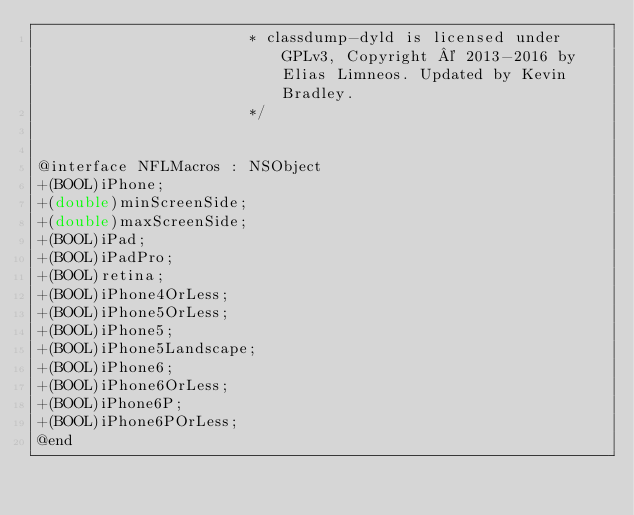<code> <loc_0><loc_0><loc_500><loc_500><_C_>                       * classdump-dyld is licensed under GPLv3, Copyright © 2013-2016 by Elias Limneos. Updated by Kevin Bradley.
                       */


@interface NFLMacros : NSObject
+(BOOL)iPhone;
+(double)minScreenSide;
+(double)maxScreenSide;
+(BOOL)iPad;
+(BOOL)iPadPro;
+(BOOL)retina;
+(BOOL)iPhone4OrLess;
+(BOOL)iPhone5OrLess;
+(BOOL)iPhone5;
+(BOOL)iPhone5Landscape;
+(BOOL)iPhone6;
+(BOOL)iPhone6OrLess;
+(BOOL)iPhone6P;
+(BOOL)iPhone6POrLess;
@end

</code> 